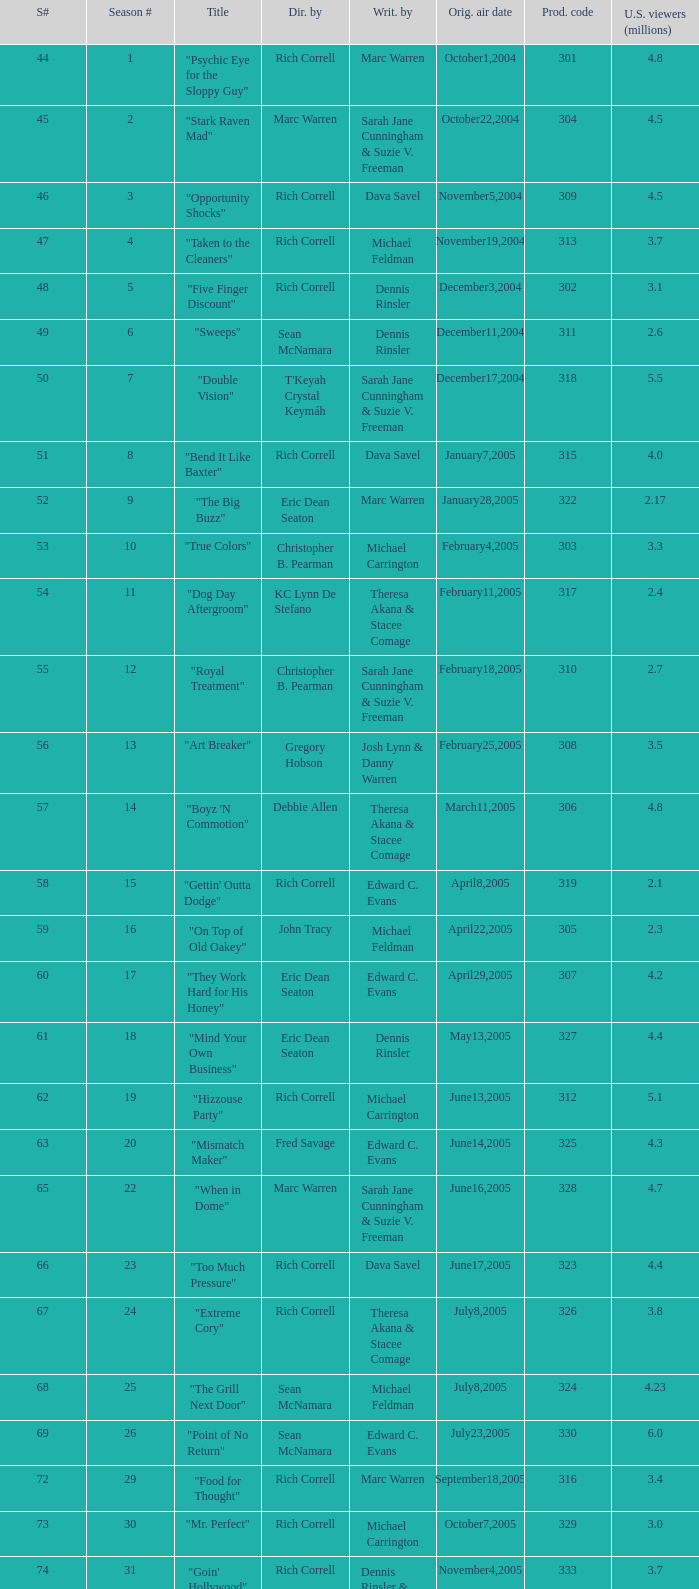What number episode of the season was titled "Vision Impossible"? 34.0. 